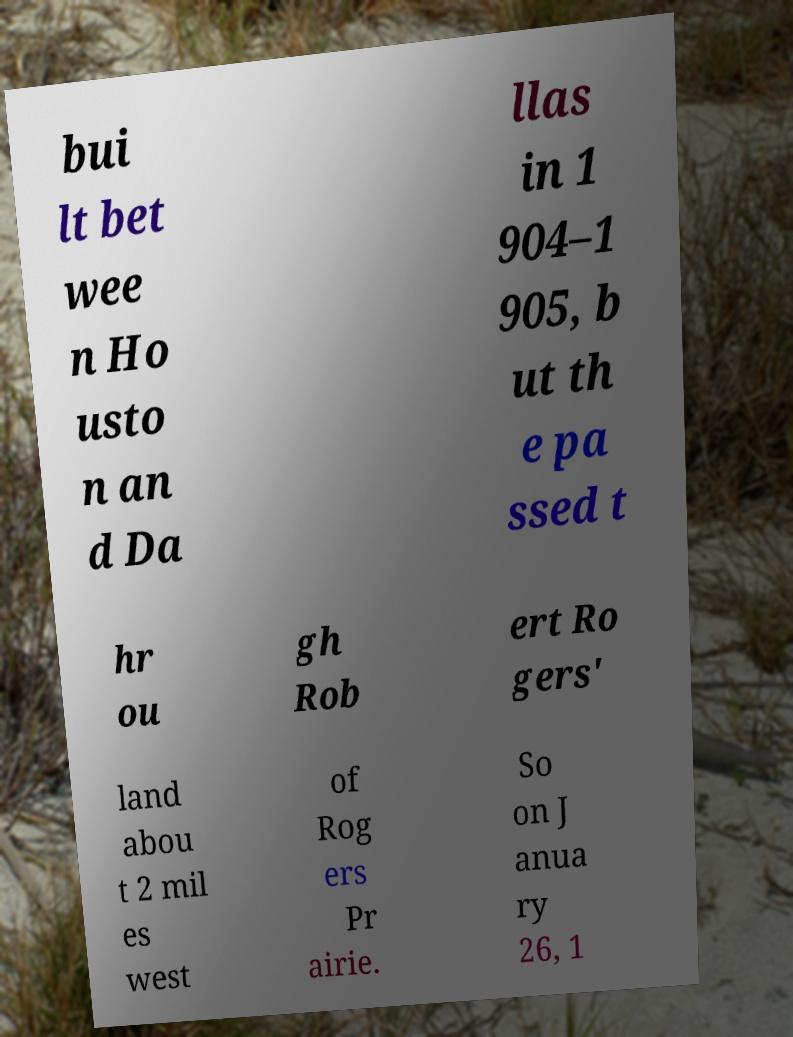Can you accurately transcribe the text from the provided image for me? bui lt bet wee n Ho usto n an d Da llas in 1 904–1 905, b ut th e pa ssed t hr ou gh Rob ert Ro gers' land abou t 2 mil es west of Rog ers Pr airie. So on J anua ry 26, 1 